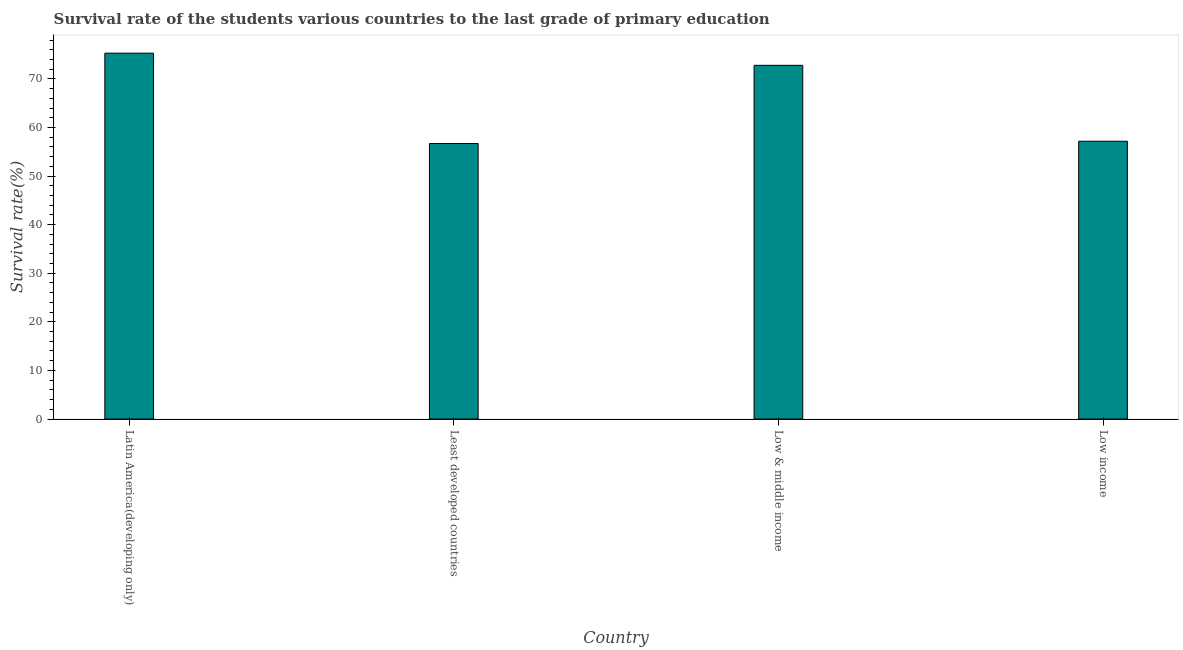Does the graph contain any zero values?
Provide a succinct answer. No. Does the graph contain grids?
Keep it short and to the point. No. What is the title of the graph?
Ensure brevity in your answer.  Survival rate of the students various countries to the last grade of primary education. What is the label or title of the X-axis?
Your answer should be very brief. Country. What is the label or title of the Y-axis?
Your answer should be compact. Survival rate(%). What is the survival rate in primary education in Low income?
Give a very brief answer. 57.17. Across all countries, what is the maximum survival rate in primary education?
Your answer should be very brief. 75.3. Across all countries, what is the minimum survival rate in primary education?
Offer a very short reply. 56.7. In which country was the survival rate in primary education maximum?
Provide a succinct answer. Latin America(developing only). In which country was the survival rate in primary education minimum?
Ensure brevity in your answer.  Least developed countries. What is the sum of the survival rate in primary education?
Your answer should be very brief. 261.96. What is the difference between the survival rate in primary education in Low & middle income and Low income?
Provide a succinct answer. 15.62. What is the average survival rate in primary education per country?
Your answer should be compact. 65.49. What is the median survival rate in primary education?
Make the answer very short. 64.98. What is the ratio of the survival rate in primary education in Latin America(developing only) to that in Low income?
Your answer should be very brief. 1.32. What is the difference between the highest and the second highest survival rate in primary education?
Your answer should be compact. 2.5. What is the difference between the highest and the lowest survival rate in primary education?
Provide a succinct answer. 18.6. In how many countries, is the survival rate in primary education greater than the average survival rate in primary education taken over all countries?
Your response must be concise. 2. How many bars are there?
Give a very brief answer. 4. Are all the bars in the graph horizontal?
Give a very brief answer. No. What is the difference between two consecutive major ticks on the Y-axis?
Offer a very short reply. 10. Are the values on the major ticks of Y-axis written in scientific E-notation?
Your answer should be compact. No. What is the Survival rate(%) of Latin America(developing only)?
Offer a terse response. 75.3. What is the Survival rate(%) in Least developed countries?
Provide a succinct answer. 56.7. What is the Survival rate(%) in Low & middle income?
Your answer should be very brief. 72.79. What is the Survival rate(%) of Low income?
Make the answer very short. 57.17. What is the difference between the Survival rate(%) in Latin America(developing only) and Least developed countries?
Make the answer very short. 18.6. What is the difference between the Survival rate(%) in Latin America(developing only) and Low & middle income?
Give a very brief answer. 2.5. What is the difference between the Survival rate(%) in Latin America(developing only) and Low income?
Provide a short and direct response. 18.13. What is the difference between the Survival rate(%) in Least developed countries and Low & middle income?
Make the answer very short. -16.1. What is the difference between the Survival rate(%) in Least developed countries and Low income?
Provide a succinct answer. -0.47. What is the difference between the Survival rate(%) in Low & middle income and Low income?
Provide a succinct answer. 15.62. What is the ratio of the Survival rate(%) in Latin America(developing only) to that in Least developed countries?
Give a very brief answer. 1.33. What is the ratio of the Survival rate(%) in Latin America(developing only) to that in Low & middle income?
Your response must be concise. 1.03. What is the ratio of the Survival rate(%) in Latin America(developing only) to that in Low income?
Offer a terse response. 1.32. What is the ratio of the Survival rate(%) in Least developed countries to that in Low & middle income?
Provide a short and direct response. 0.78. What is the ratio of the Survival rate(%) in Least developed countries to that in Low income?
Make the answer very short. 0.99. What is the ratio of the Survival rate(%) in Low & middle income to that in Low income?
Keep it short and to the point. 1.27. 